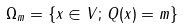Convert formula to latex. <formula><loc_0><loc_0><loc_500><loc_500>\Omega _ { m } = \left \{ x \in V ; \, Q ( x ) = m \right \}</formula> 